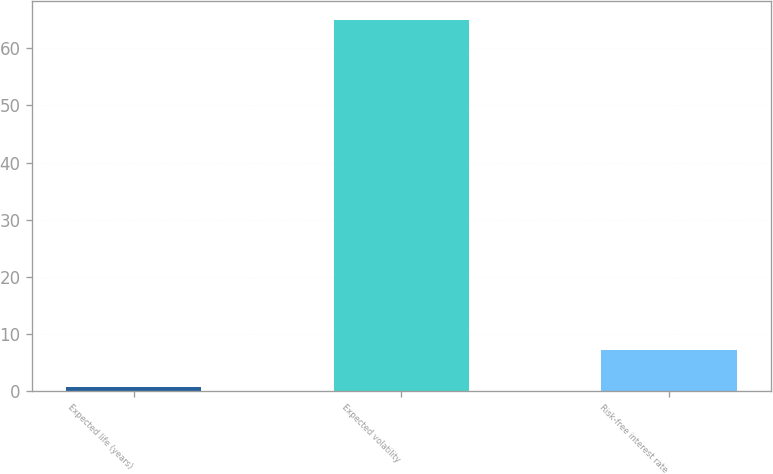Convert chart. <chart><loc_0><loc_0><loc_500><loc_500><bar_chart><fcel>Expected life (years)<fcel>Expected volatility<fcel>Risk-free interest rate<nl><fcel>0.8<fcel>65<fcel>7.22<nl></chart> 